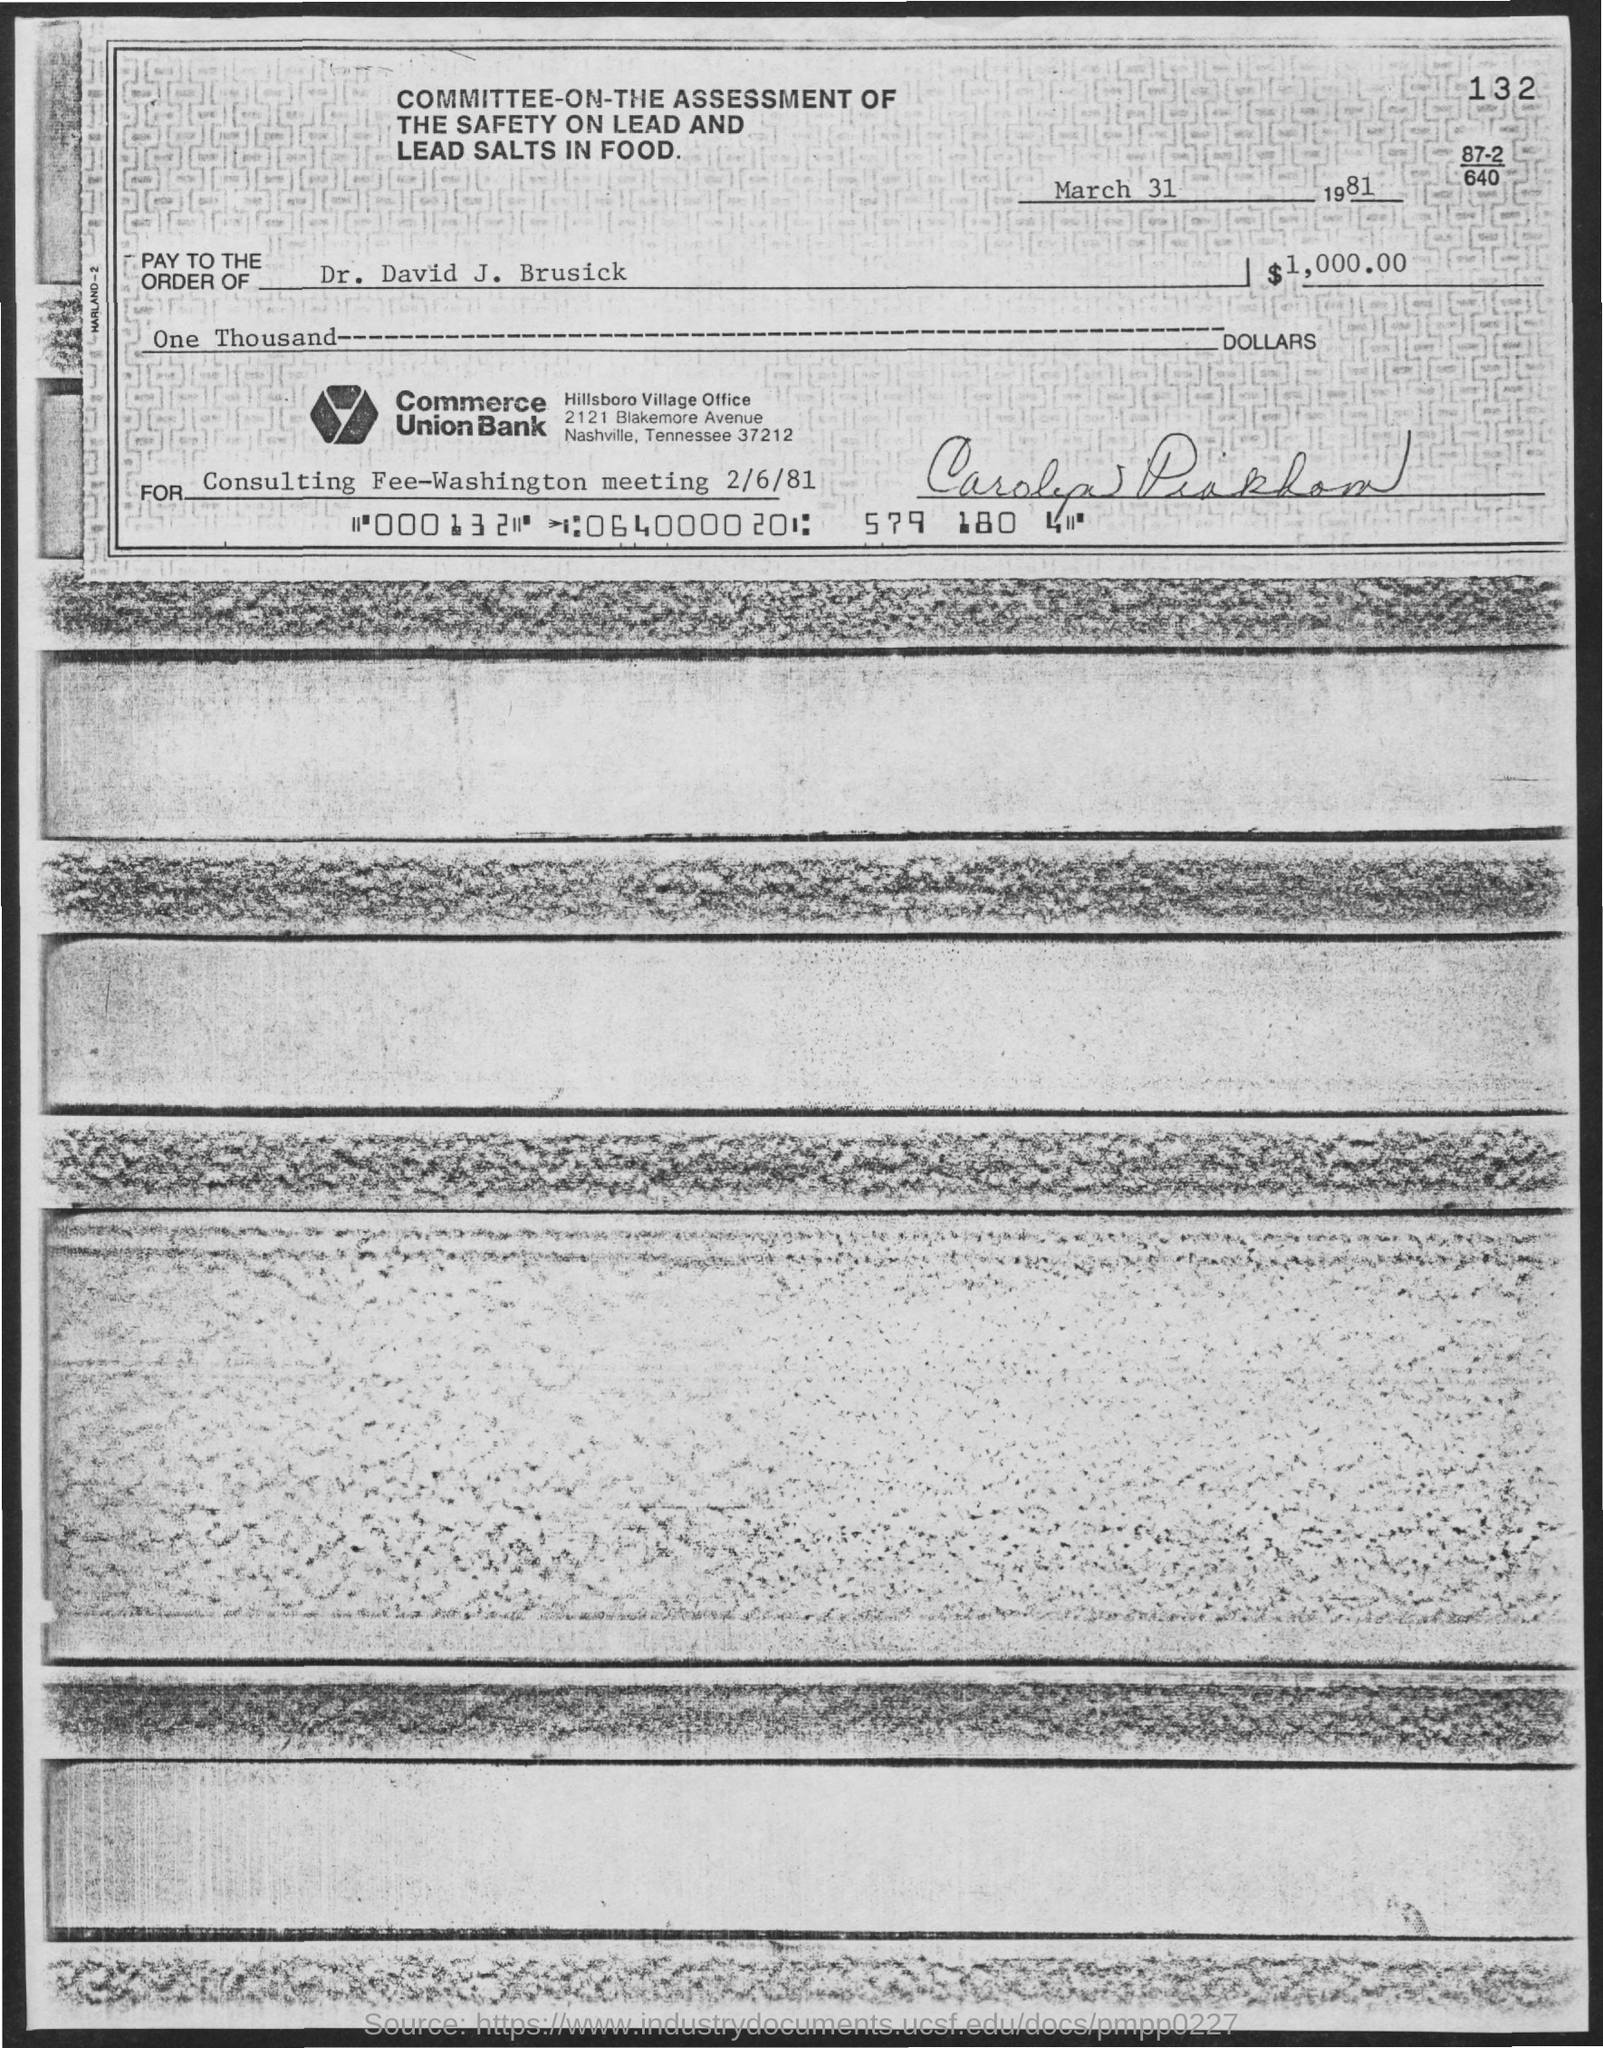Draw attention to some important aspects in this diagram. The document in question is titled "Committee-on-the assessment of the safety on lead and lead salts in food. The date mentioned at the top of the document is March 31, 1981. The name of the Village Office located in Hillsboro is Hillsboro Village Office. The number at the top right corner of the document is 132. 